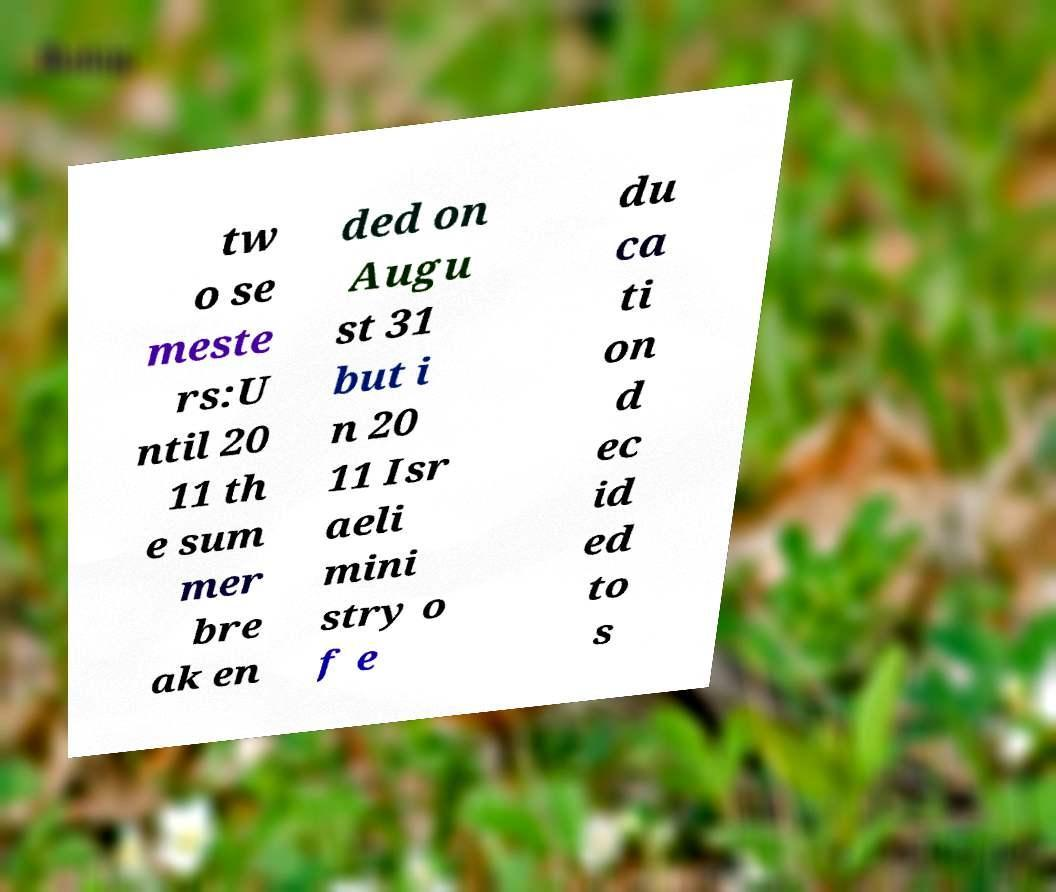Can you read and provide the text displayed in the image?This photo seems to have some interesting text. Can you extract and type it out for me? tw o se meste rs:U ntil 20 11 th e sum mer bre ak en ded on Augu st 31 but i n 20 11 Isr aeli mini stry o f e du ca ti on d ec id ed to s 